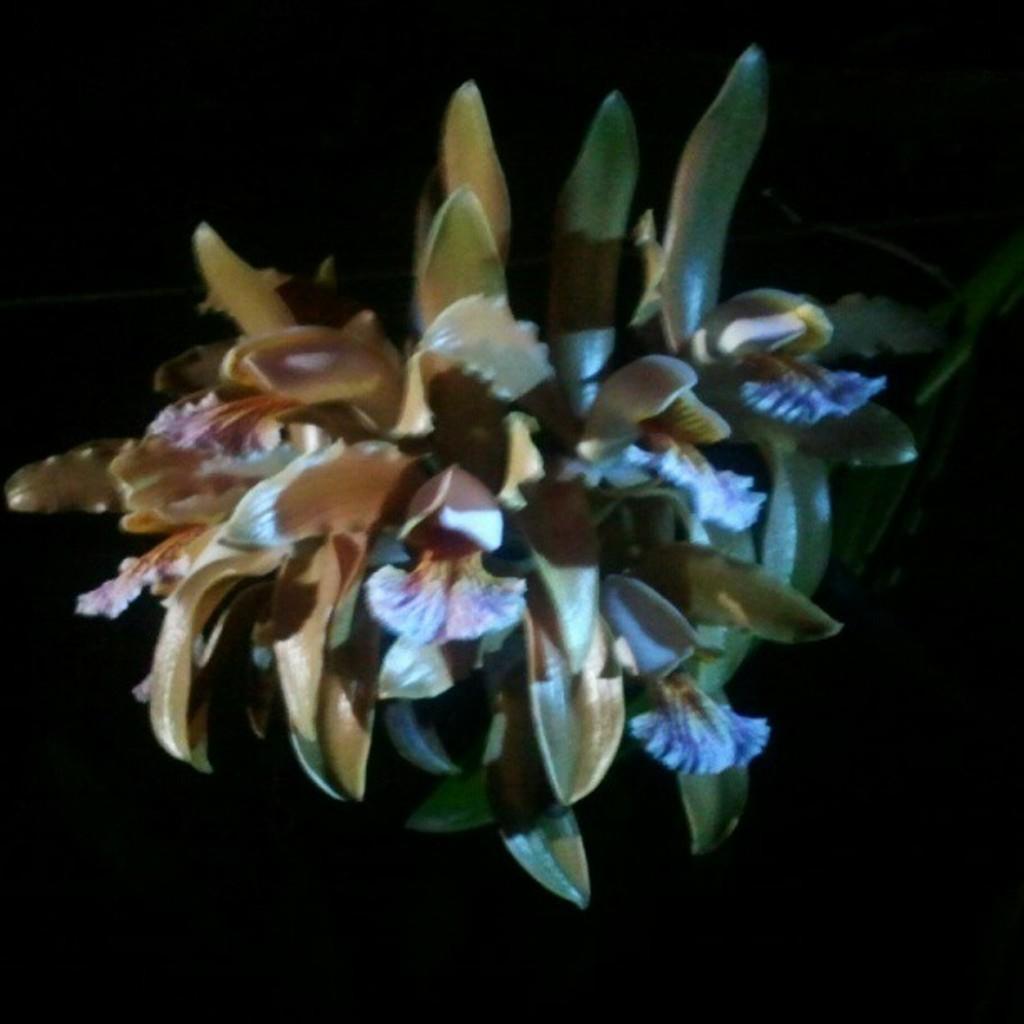In one or two sentences, can you explain what this image depicts? In the image it looks like a flower plant and the background of the plant is blur. 